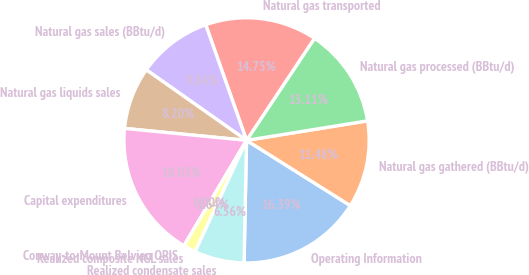Convert chart to OTSL. <chart><loc_0><loc_0><loc_500><loc_500><pie_chart><fcel>Operating Information<fcel>Natural gas gathered (BBtu/d)<fcel>Natural gas processed (BBtu/d)<fcel>Natural gas transported<fcel>Natural gas sales (BBtu/d)<fcel>Natural gas liquids sales<fcel>Capital expenditures<fcel>Conway-to-Mount Belvieu OPIS<fcel>Realized composite NGL sales<fcel>Realized condensate sales<nl><fcel>16.39%<fcel>11.48%<fcel>13.11%<fcel>14.75%<fcel>9.84%<fcel>8.2%<fcel>18.03%<fcel>0.0%<fcel>1.64%<fcel>6.56%<nl></chart> 